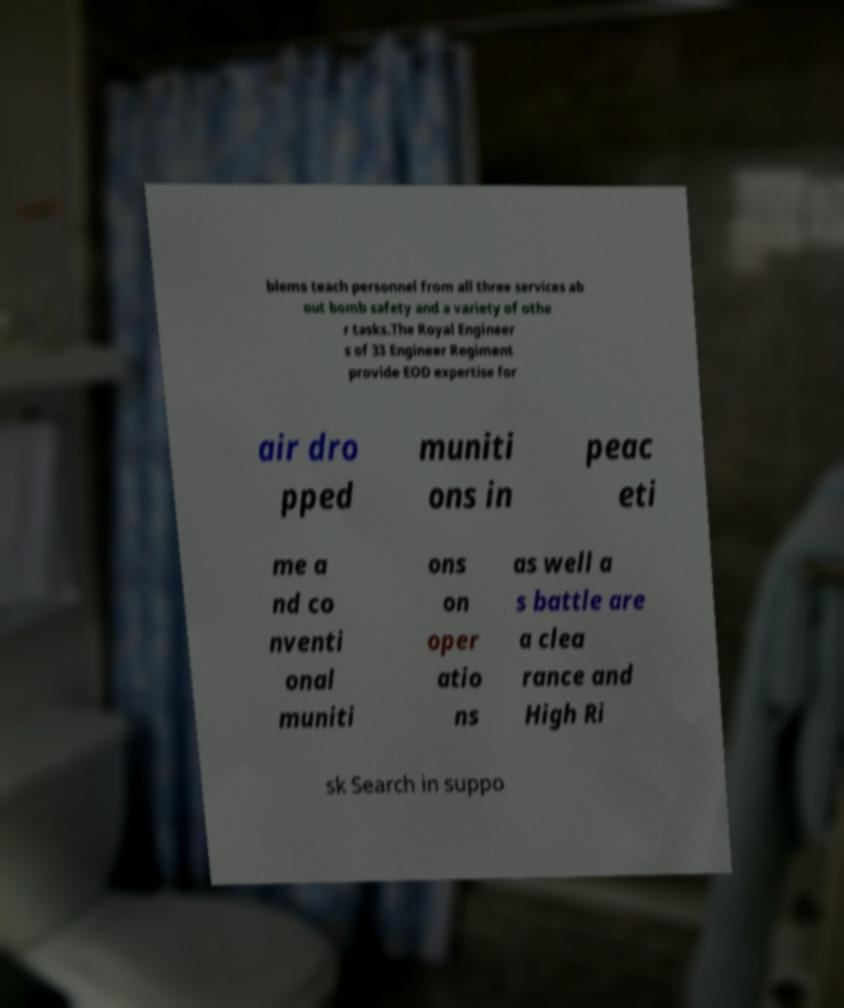Can you accurately transcribe the text from the provided image for me? blems teach personnel from all three services ab out bomb safety and a variety of othe r tasks.The Royal Engineer s of 33 Engineer Regiment provide EOD expertise for air dro pped muniti ons in peac eti me a nd co nventi onal muniti ons on oper atio ns as well a s battle are a clea rance and High Ri sk Search in suppo 